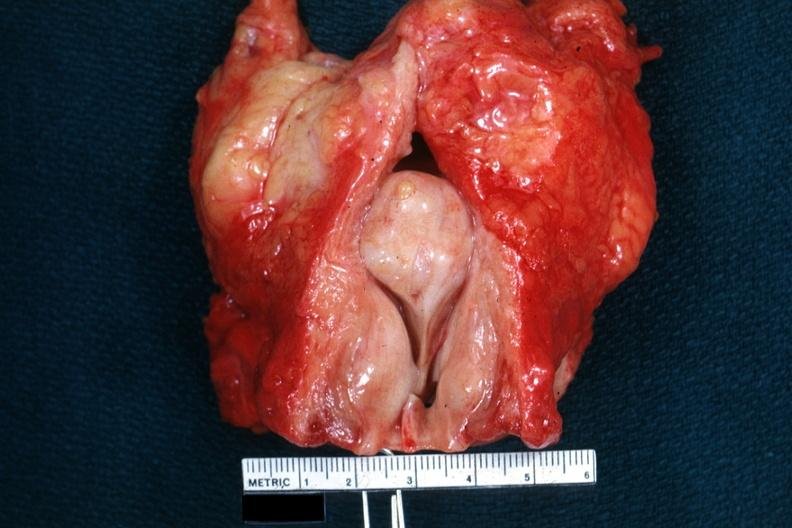what does so-called median bar show bladder well?
Answer the question using a single word or phrase. Bar not 